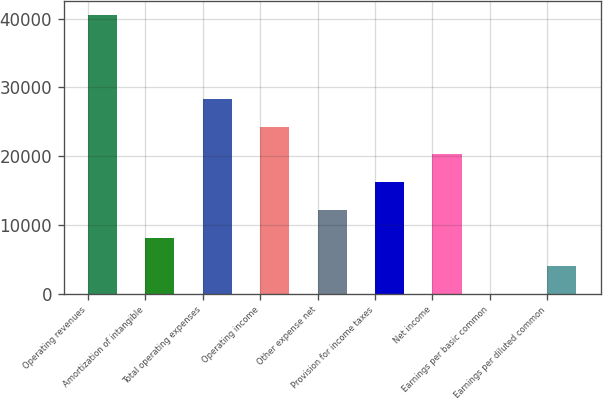<chart> <loc_0><loc_0><loc_500><loc_500><bar_chart><fcel>Operating revenues<fcel>Amortization of intangible<fcel>Total operating expenses<fcel>Operating income<fcel>Other expense net<fcel>Provision for income taxes<fcel>Net income<fcel>Earnings per basic common<fcel>Earnings per diluted common<nl><fcel>40487<fcel>8097.47<fcel>28340.9<fcel>24292.2<fcel>12146.2<fcel>16194.9<fcel>20243.5<fcel>0.09<fcel>4048.78<nl></chart> 